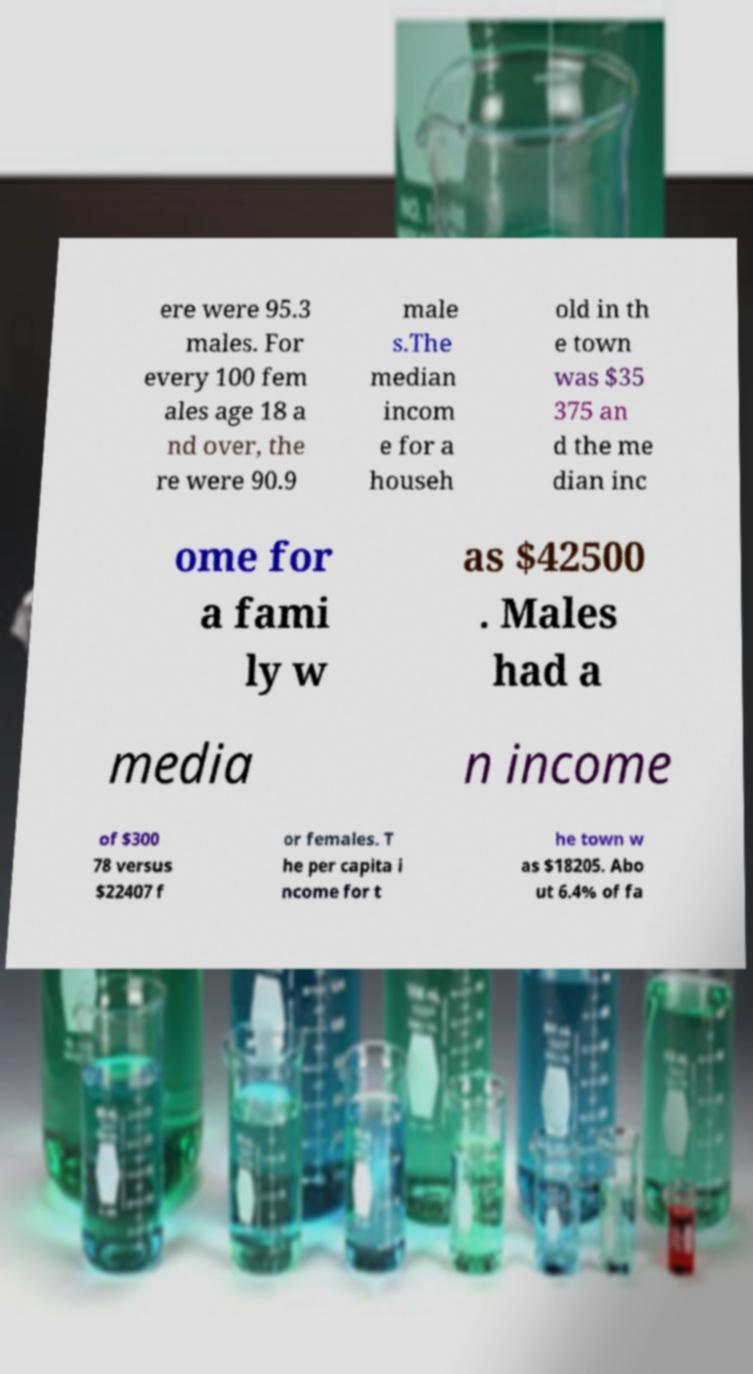I need the written content from this picture converted into text. Can you do that? ere were 95.3 males. For every 100 fem ales age 18 a nd over, the re were 90.9 male s.The median incom e for a househ old in th e town was $35 375 an d the me dian inc ome for a fami ly w as $42500 . Males had a media n income of $300 78 versus $22407 f or females. T he per capita i ncome for t he town w as $18205. Abo ut 6.4% of fa 